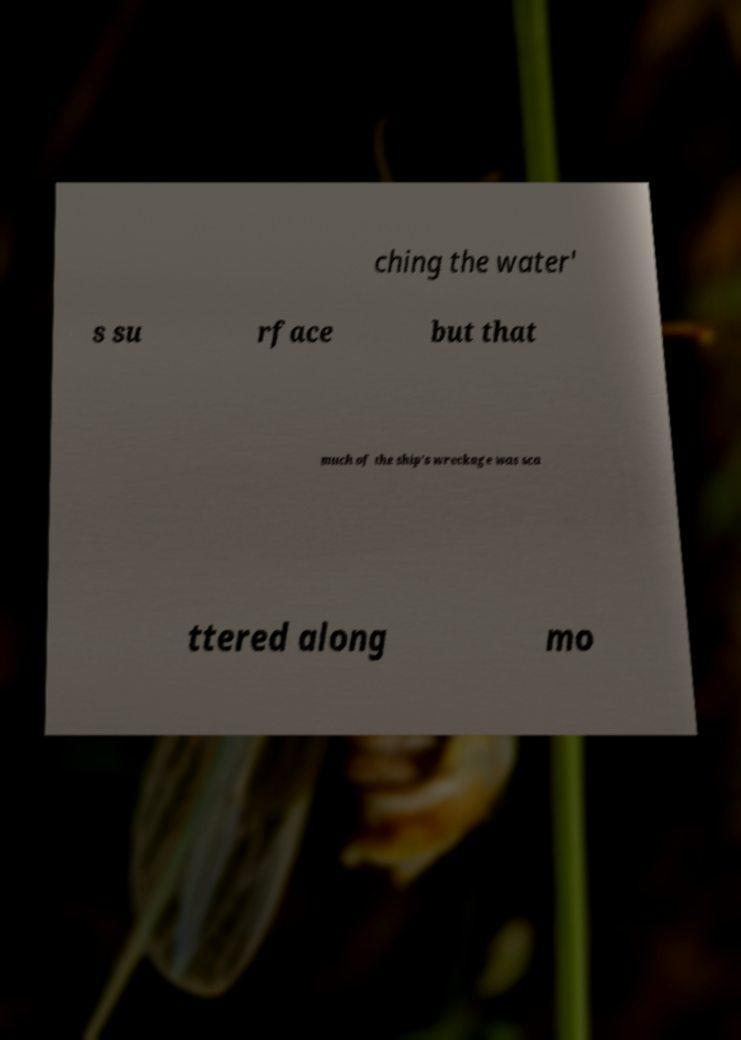There's text embedded in this image that I need extracted. Can you transcribe it verbatim? ching the water' s su rface but that much of the ship's wreckage was sca ttered along mo 